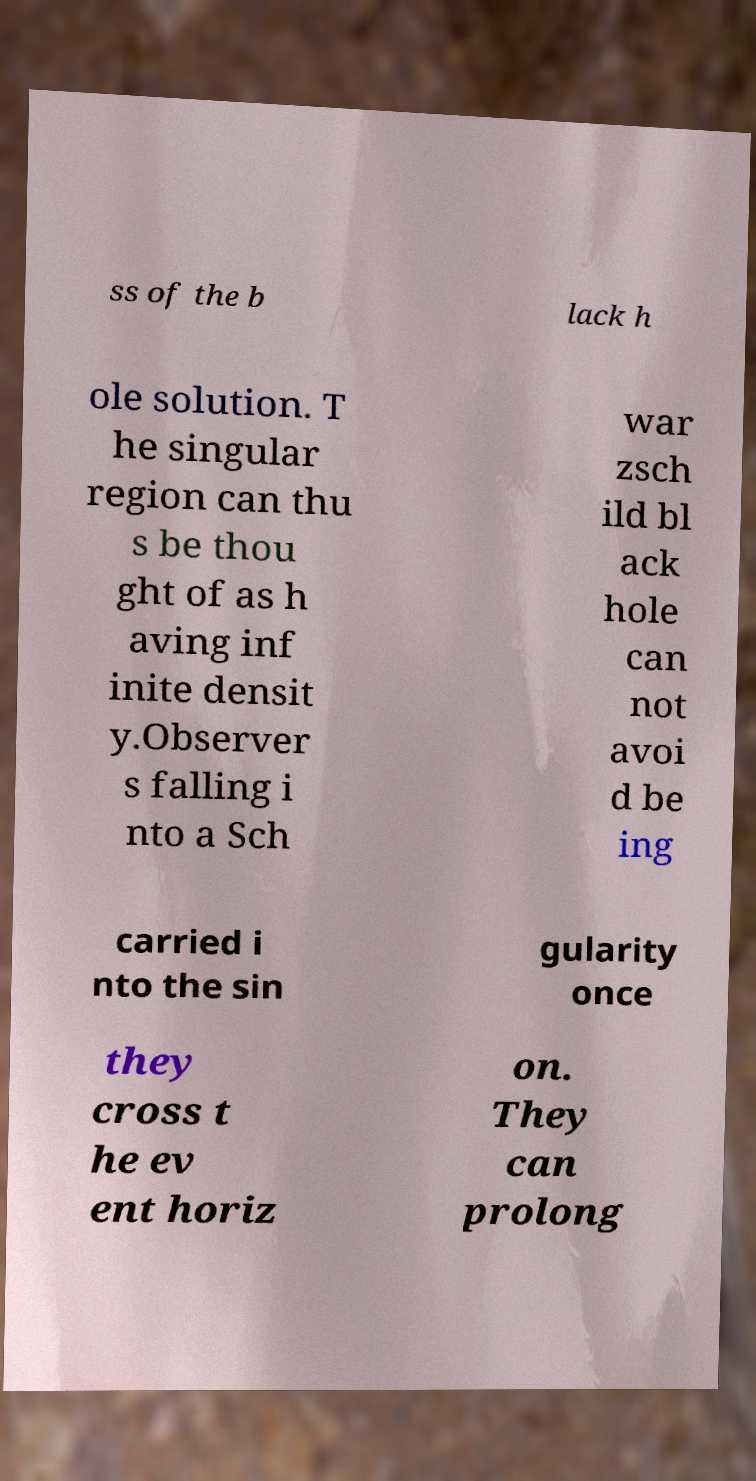Could you extract and type out the text from this image? ss of the b lack h ole solution. T he singular region can thu s be thou ght of as h aving inf inite densit y.Observer s falling i nto a Sch war zsch ild bl ack hole can not avoi d be ing carried i nto the sin gularity once they cross t he ev ent horiz on. They can prolong 